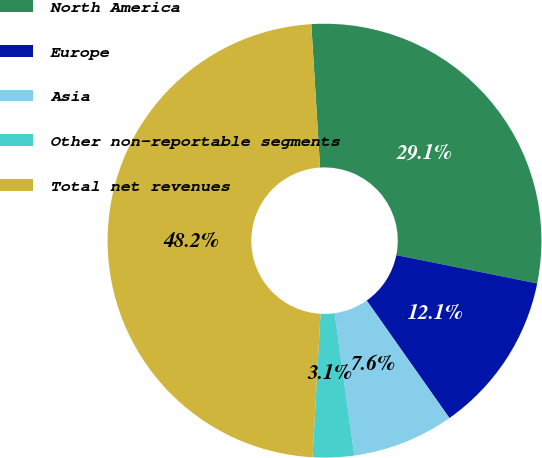Convert chart. <chart><loc_0><loc_0><loc_500><loc_500><pie_chart><fcel>North America<fcel>Europe<fcel>Asia<fcel>Other non-reportable segments<fcel>Total net revenues<nl><fcel>29.13%<fcel>12.08%<fcel>7.57%<fcel>3.07%<fcel>48.15%<nl></chart> 